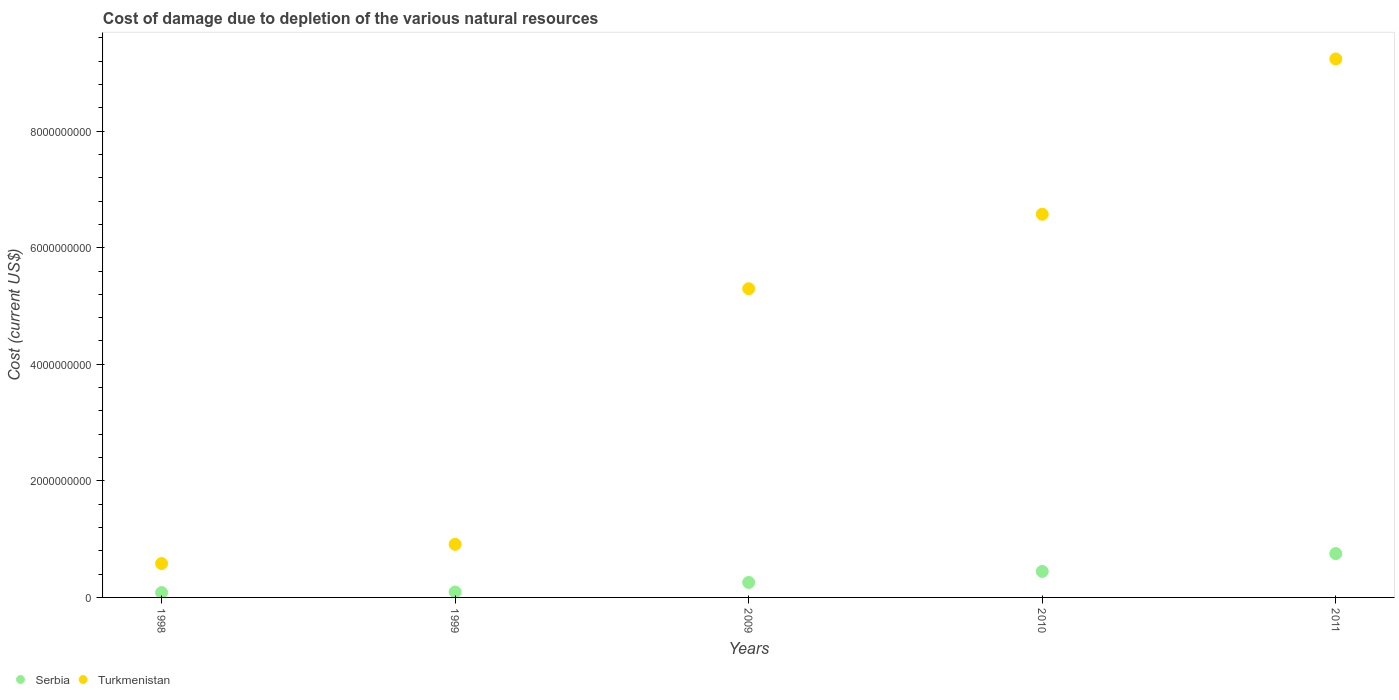How many different coloured dotlines are there?
Give a very brief answer. 2. Is the number of dotlines equal to the number of legend labels?
Provide a short and direct response. Yes. What is the cost of damage caused due to the depletion of various natural resources in Turkmenistan in 2010?
Ensure brevity in your answer.  6.57e+09. Across all years, what is the maximum cost of damage caused due to the depletion of various natural resources in Serbia?
Provide a short and direct response. 7.52e+08. Across all years, what is the minimum cost of damage caused due to the depletion of various natural resources in Serbia?
Ensure brevity in your answer.  8.31e+07. What is the total cost of damage caused due to the depletion of various natural resources in Turkmenistan in the graph?
Your response must be concise. 2.26e+1. What is the difference between the cost of damage caused due to the depletion of various natural resources in Serbia in 2009 and that in 2010?
Your answer should be compact. -1.89e+08. What is the difference between the cost of damage caused due to the depletion of various natural resources in Turkmenistan in 1998 and the cost of damage caused due to the depletion of various natural resources in Serbia in 2010?
Your answer should be compact. 1.35e+08. What is the average cost of damage caused due to the depletion of various natural resources in Serbia per year?
Make the answer very short. 3.26e+08. In the year 2009, what is the difference between the cost of damage caused due to the depletion of various natural resources in Turkmenistan and cost of damage caused due to the depletion of various natural resources in Serbia?
Your answer should be very brief. 5.04e+09. In how many years, is the cost of damage caused due to the depletion of various natural resources in Serbia greater than 400000000 US$?
Give a very brief answer. 2. What is the ratio of the cost of damage caused due to the depletion of various natural resources in Serbia in 1998 to that in 2011?
Provide a succinct answer. 0.11. Is the difference between the cost of damage caused due to the depletion of various natural resources in Turkmenistan in 1999 and 2011 greater than the difference between the cost of damage caused due to the depletion of various natural resources in Serbia in 1999 and 2011?
Your answer should be very brief. No. What is the difference between the highest and the second highest cost of damage caused due to the depletion of various natural resources in Turkmenistan?
Keep it short and to the point. 2.66e+09. What is the difference between the highest and the lowest cost of damage caused due to the depletion of various natural resources in Turkmenistan?
Give a very brief answer. 8.66e+09. Is the sum of the cost of damage caused due to the depletion of various natural resources in Serbia in 1998 and 1999 greater than the maximum cost of damage caused due to the depletion of various natural resources in Turkmenistan across all years?
Offer a very short reply. No. Does the cost of damage caused due to the depletion of various natural resources in Serbia monotonically increase over the years?
Make the answer very short. Yes. Is the cost of damage caused due to the depletion of various natural resources in Serbia strictly greater than the cost of damage caused due to the depletion of various natural resources in Turkmenistan over the years?
Provide a succinct answer. No. Is the cost of damage caused due to the depletion of various natural resources in Turkmenistan strictly less than the cost of damage caused due to the depletion of various natural resources in Serbia over the years?
Your answer should be compact. No. How many dotlines are there?
Your answer should be very brief. 2. How many years are there in the graph?
Offer a terse response. 5. Does the graph contain any zero values?
Ensure brevity in your answer.  No. How are the legend labels stacked?
Give a very brief answer. Horizontal. What is the title of the graph?
Offer a terse response. Cost of damage due to depletion of the various natural resources. What is the label or title of the Y-axis?
Your answer should be compact. Cost (current US$). What is the Cost (current US$) in Serbia in 1998?
Your response must be concise. 8.31e+07. What is the Cost (current US$) in Turkmenistan in 1998?
Your response must be concise. 5.81e+08. What is the Cost (current US$) in Serbia in 1999?
Ensure brevity in your answer.  9.35e+07. What is the Cost (current US$) in Turkmenistan in 1999?
Ensure brevity in your answer.  9.11e+08. What is the Cost (current US$) of Serbia in 2009?
Provide a short and direct response. 2.57e+08. What is the Cost (current US$) of Turkmenistan in 2009?
Keep it short and to the point. 5.30e+09. What is the Cost (current US$) of Serbia in 2010?
Your answer should be compact. 4.46e+08. What is the Cost (current US$) of Turkmenistan in 2010?
Your response must be concise. 6.57e+09. What is the Cost (current US$) in Serbia in 2011?
Offer a very short reply. 7.52e+08. What is the Cost (current US$) of Turkmenistan in 2011?
Make the answer very short. 9.24e+09. Across all years, what is the maximum Cost (current US$) in Serbia?
Your answer should be compact. 7.52e+08. Across all years, what is the maximum Cost (current US$) in Turkmenistan?
Ensure brevity in your answer.  9.24e+09. Across all years, what is the minimum Cost (current US$) in Serbia?
Ensure brevity in your answer.  8.31e+07. Across all years, what is the minimum Cost (current US$) in Turkmenistan?
Offer a terse response. 5.81e+08. What is the total Cost (current US$) in Serbia in the graph?
Provide a short and direct response. 1.63e+09. What is the total Cost (current US$) in Turkmenistan in the graph?
Offer a very short reply. 2.26e+1. What is the difference between the Cost (current US$) in Serbia in 1998 and that in 1999?
Provide a short and direct response. -1.04e+07. What is the difference between the Cost (current US$) in Turkmenistan in 1998 and that in 1999?
Provide a short and direct response. -3.29e+08. What is the difference between the Cost (current US$) in Serbia in 1998 and that in 2009?
Provide a short and direct response. -1.74e+08. What is the difference between the Cost (current US$) in Turkmenistan in 1998 and that in 2009?
Provide a short and direct response. -4.71e+09. What is the difference between the Cost (current US$) in Serbia in 1998 and that in 2010?
Your answer should be compact. -3.63e+08. What is the difference between the Cost (current US$) in Turkmenistan in 1998 and that in 2010?
Offer a very short reply. -5.99e+09. What is the difference between the Cost (current US$) in Serbia in 1998 and that in 2011?
Provide a succinct answer. -6.69e+08. What is the difference between the Cost (current US$) in Turkmenistan in 1998 and that in 2011?
Make the answer very short. -8.66e+09. What is the difference between the Cost (current US$) in Serbia in 1999 and that in 2009?
Your response must be concise. -1.64e+08. What is the difference between the Cost (current US$) in Turkmenistan in 1999 and that in 2009?
Provide a short and direct response. -4.39e+09. What is the difference between the Cost (current US$) in Serbia in 1999 and that in 2010?
Provide a succinct answer. -3.53e+08. What is the difference between the Cost (current US$) of Turkmenistan in 1999 and that in 2010?
Your answer should be very brief. -5.66e+09. What is the difference between the Cost (current US$) in Serbia in 1999 and that in 2011?
Your answer should be compact. -6.59e+08. What is the difference between the Cost (current US$) of Turkmenistan in 1999 and that in 2011?
Provide a succinct answer. -8.33e+09. What is the difference between the Cost (current US$) in Serbia in 2009 and that in 2010?
Keep it short and to the point. -1.89e+08. What is the difference between the Cost (current US$) in Turkmenistan in 2009 and that in 2010?
Your answer should be very brief. -1.28e+09. What is the difference between the Cost (current US$) of Serbia in 2009 and that in 2011?
Your answer should be very brief. -4.95e+08. What is the difference between the Cost (current US$) of Turkmenistan in 2009 and that in 2011?
Give a very brief answer. -3.94e+09. What is the difference between the Cost (current US$) of Serbia in 2010 and that in 2011?
Ensure brevity in your answer.  -3.06e+08. What is the difference between the Cost (current US$) of Turkmenistan in 2010 and that in 2011?
Offer a terse response. -2.66e+09. What is the difference between the Cost (current US$) in Serbia in 1998 and the Cost (current US$) in Turkmenistan in 1999?
Ensure brevity in your answer.  -8.28e+08. What is the difference between the Cost (current US$) of Serbia in 1998 and the Cost (current US$) of Turkmenistan in 2009?
Provide a succinct answer. -5.21e+09. What is the difference between the Cost (current US$) in Serbia in 1998 and the Cost (current US$) in Turkmenistan in 2010?
Your response must be concise. -6.49e+09. What is the difference between the Cost (current US$) of Serbia in 1998 and the Cost (current US$) of Turkmenistan in 2011?
Ensure brevity in your answer.  -9.16e+09. What is the difference between the Cost (current US$) of Serbia in 1999 and the Cost (current US$) of Turkmenistan in 2009?
Your answer should be compact. -5.20e+09. What is the difference between the Cost (current US$) in Serbia in 1999 and the Cost (current US$) in Turkmenistan in 2010?
Your response must be concise. -6.48e+09. What is the difference between the Cost (current US$) of Serbia in 1999 and the Cost (current US$) of Turkmenistan in 2011?
Give a very brief answer. -9.14e+09. What is the difference between the Cost (current US$) in Serbia in 2009 and the Cost (current US$) in Turkmenistan in 2010?
Your answer should be very brief. -6.32e+09. What is the difference between the Cost (current US$) of Serbia in 2009 and the Cost (current US$) of Turkmenistan in 2011?
Offer a terse response. -8.98e+09. What is the difference between the Cost (current US$) in Serbia in 2010 and the Cost (current US$) in Turkmenistan in 2011?
Offer a terse response. -8.79e+09. What is the average Cost (current US$) in Serbia per year?
Ensure brevity in your answer.  3.26e+08. What is the average Cost (current US$) of Turkmenistan per year?
Offer a very short reply. 4.52e+09. In the year 1998, what is the difference between the Cost (current US$) of Serbia and Cost (current US$) of Turkmenistan?
Ensure brevity in your answer.  -4.98e+08. In the year 1999, what is the difference between the Cost (current US$) of Serbia and Cost (current US$) of Turkmenistan?
Give a very brief answer. -8.17e+08. In the year 2009, what is the difference between the Cost (current US$) of Serbia and Cost (current US$) of Turkmenistan?
Offer a very short reply. -5.04e+09. In the year 2010, what is the difference between the Cost (current US$) of Serbia and Cost (current US$) of Turkmenistan?
Provide a succinct answer. -6.13e+09. In the year 2011, what is the difference between the Cost (current US$) in Serbia and Cost (current US$) in Turkmenistan?
Your answer should be very brief. -8.49e+09. What is the ratio of the Cost (current US$) in Serbia in 1998 to that in 1999?
Keep it short and to the point. 0.89. What is the ratio of the Cost (current US$) in Turkmenistan in 1998 to that in 1999?
Your answer should be very brief. 0.64. What is the ratio of the Cost (current US$) in Serbia in 1998 to that in 2009?
Offer a very short reply. 0.32. What is the ratio of the Cost (current US$) of Turkmenistan in 1998 to that in 2009?
Offer a very short reply. 0.11. What is the ratio of the Cost (current US$) in Serbia in 1998 to that in 2010?
Your response must be concise. 0.19. What is the ratio of the Cost (current US$) of Turkmenistan in 1998 to that in 2010?
Your answer should be compact. 0.09. What is the ratio of the Cost (current US$) of Serbia in 1998 to that in 2011?
Offer a very short reply. 0.11. What is the ratio of the Cost (current US$) in Turkmenistan in 1998 to that in 2011?
Give a very brief answer. 0.06. What is the ratio of the Cost (current US$) of Serbia in 1999 to that in 2009?
Provide a short and direct response. 0.36. What is the ratio of the Cost (current US$) in Turkmenistan in 1999 to that in 2009?
Your answer should be very brief. 0.17. What is the ratio of the Cost (current US$) of Serbia in 1999 to that in 2010?
Your response must be concise. 0.21. What is the ratio of the Cost (current US$) of Turkmenistan in 1999 to that in 2010?
Provide a short and direct response. 0.14. What is the ratio of the Cost (current US$) in Serbia in 1999 to that in 2011?
Give a very brief answer. 0.12. What is the ratio of the Cost (current US$) in Turkmenistan in 1999 to that in 2011?
Make the answer very short. 0.1. What is the ratio of the Cost (current US$) in Serbia in 2009 to that in 2010?
Provide a succinct answer. 0.58. What is the ratio of the Cost (current US$) in Turkmenistan in 2009 to that in 2010?
Make the answer very short. 0.81. What is the ratio of the Cost (current US$) in Serbia in 2009 to that in 2011?
Provide a succinct answer. 0.34. What is the ratio of the Cost (current US$) of Turkmenistan in 2009 to that in 2011?
Offer a very short reply. 0.57. What is the ratio of the Cost (current US$) of Serbia in 2010 to that in 2011?
Your response must be concise. 0.59. What is the ratio of the Cost (current US$) in Turkmenistan in 2010 to that in 2011?
Ensure brevity in your answer.  0.71. What is the difference between the highest and the second highest Cost (current US$) of Serbia?
Provide a short and direct response. 3.06e+08. What is the difference between the highest and the second highest Cost (current US$) in Turkmenistan?
Provide a short and direct response. 2.66e+09. What is the difference between the highest and the lowest Cost (current US$) of Serbia?
Provide a short and direct response. 6.69e+08. What is the difference between the highest and the lowest Cost (current US$) in Turkmenistan?
Make the answer very short. 8.66e+09. 